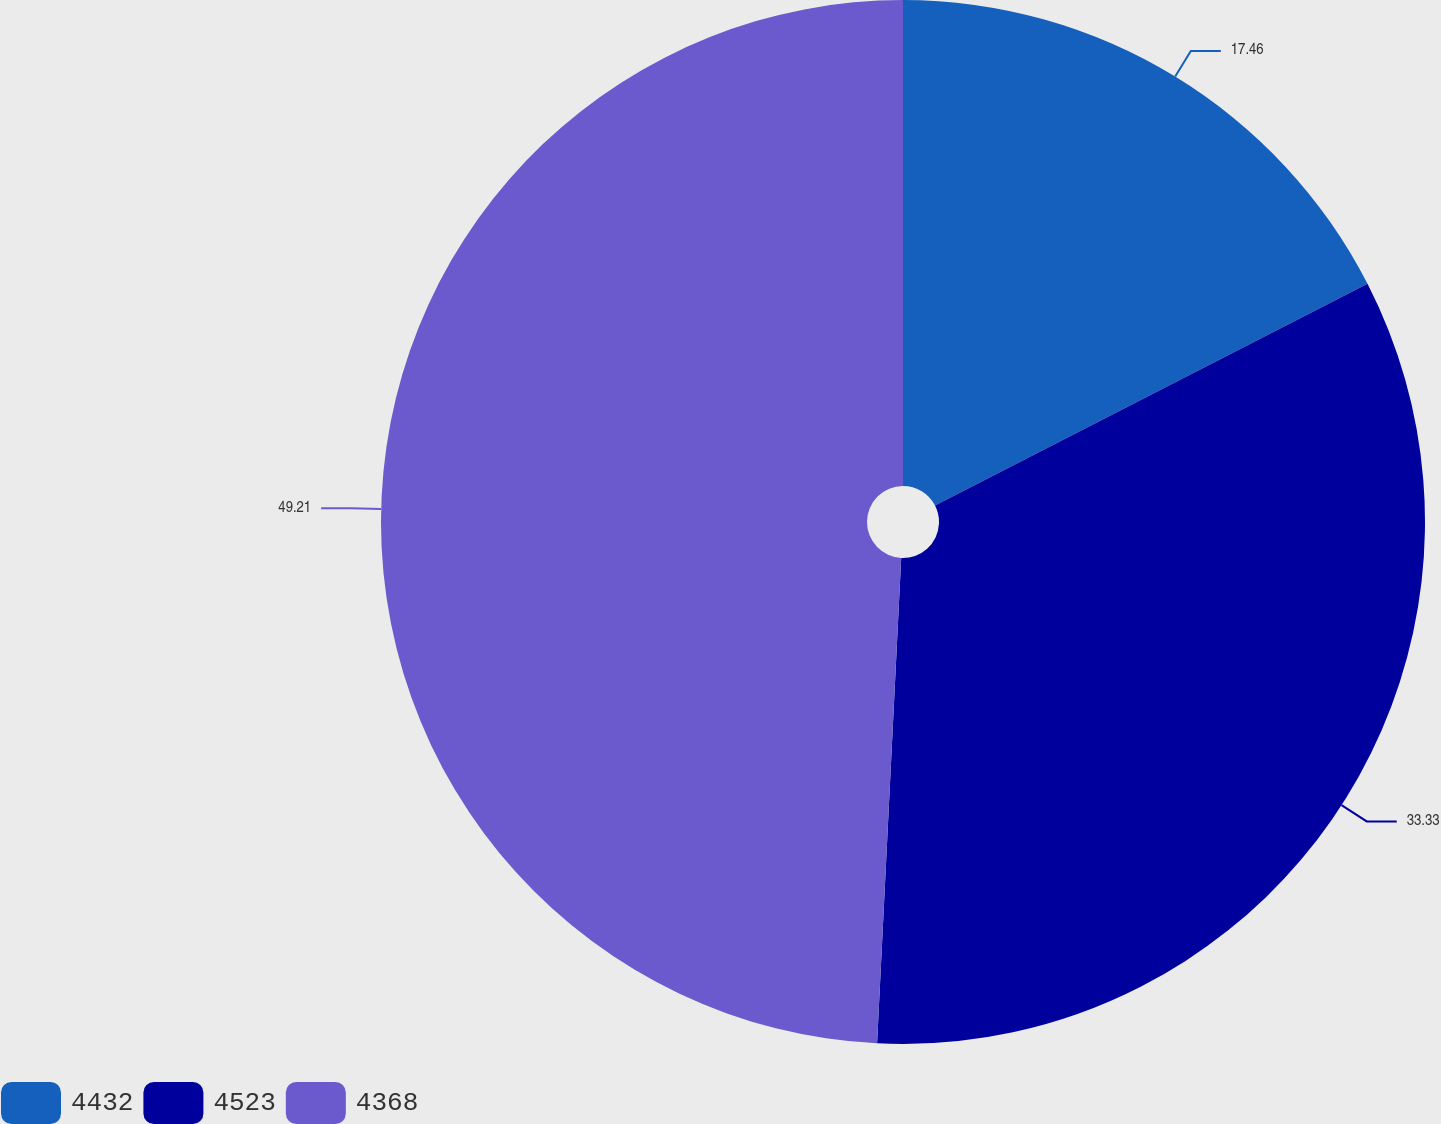<chart> <loc_0><loc_0><loc_500><loc_500><pie_chart><fcel>4432<fcel>4523<fcel>4368<nl><fcel>17.46%<fcel>33.33%<fcel>49.21%<nl></chart> 